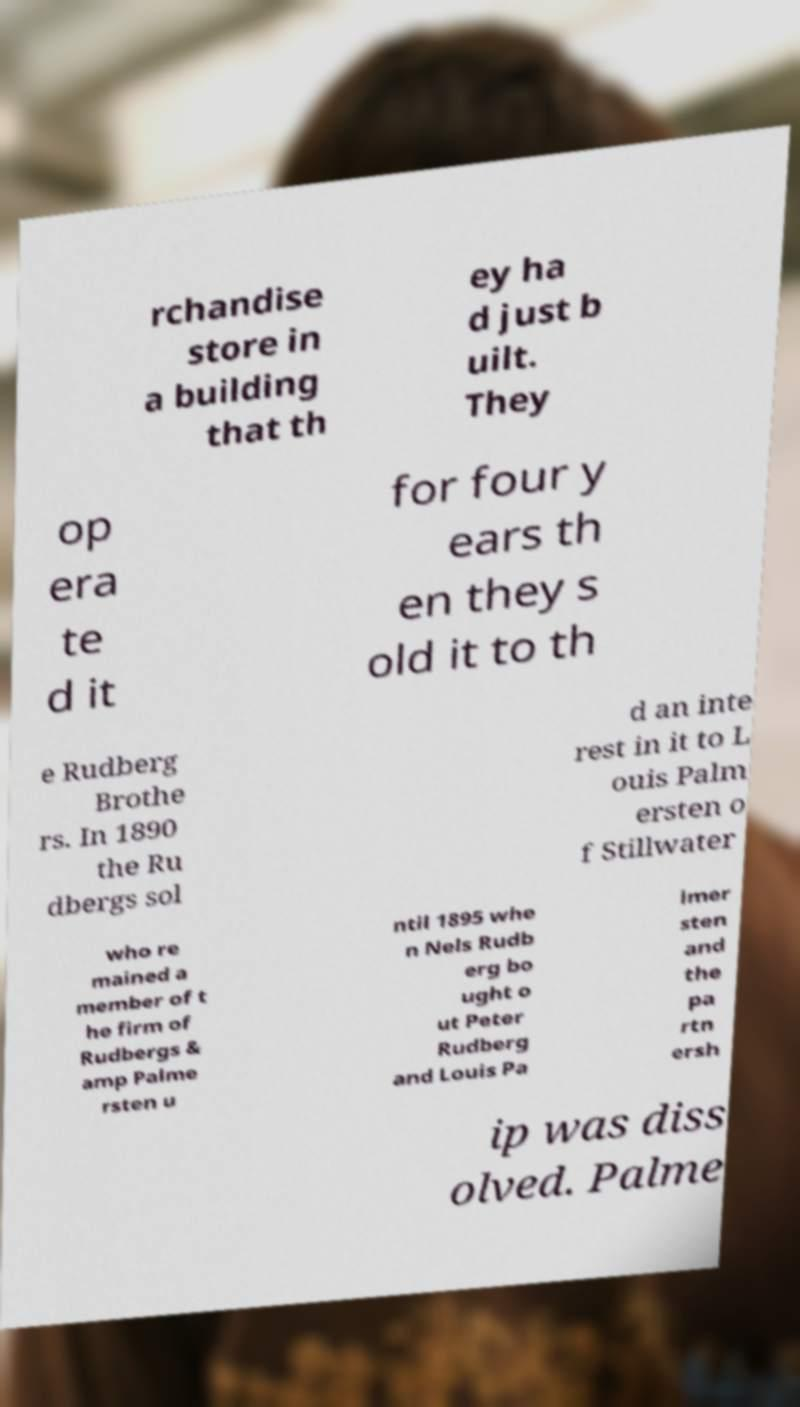Can you accurately transcribe the text from the provided image for me? rchandise store in a building that th ey ha d just b uilt. They op era te d it for four y ears th en they s old it to th e Rudberg Brothe rs. In 1890 the Ru dbergs sol d an inte rest in it to L ouis Palm ersten o f Stillwater who re mained a member of t he firm of Rudbergs & amp Palme rsten u ntil 1895 whe n Nels Rudb erg bo ught o ut Peter Rudberg and Louis Pa lmer sten and the pa rtn ersh ip was diss olved. Palme 